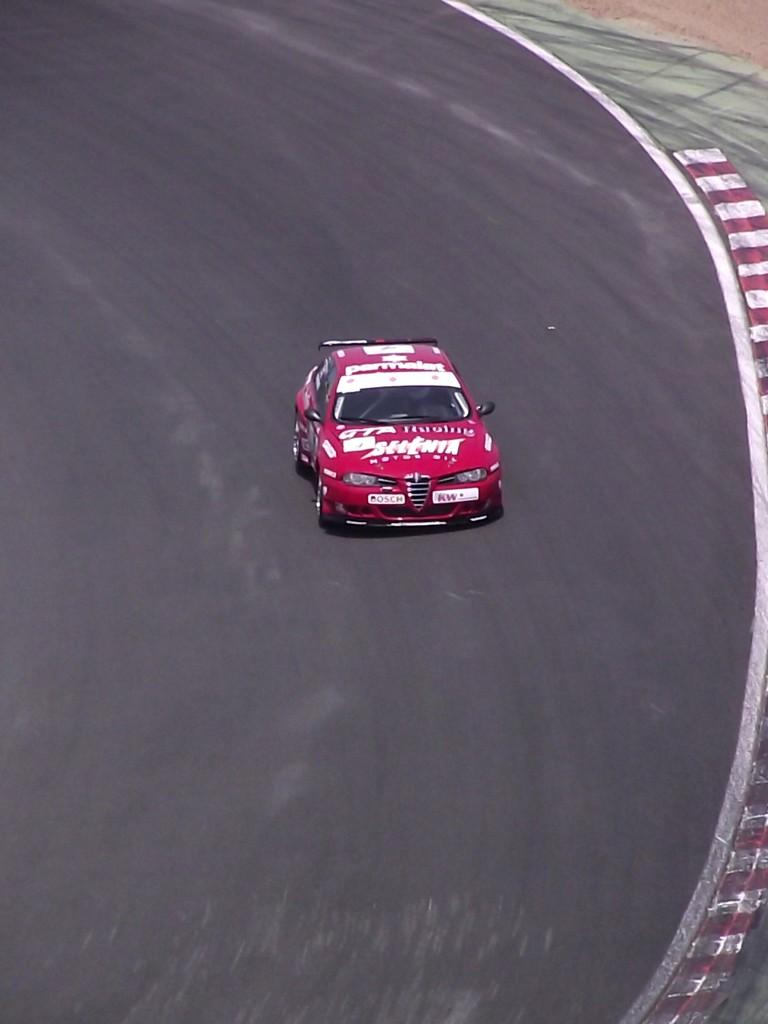What type of vehicle is in the picture? There is a sports car in the picture. Where is the sports car located? The sports car is on the road. What type of chicken is sitting on the hood of the sports car in the image? There is no chicken present in the image; it only features a sports car on the road. 